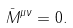Convert formula to latex. <formula><loc_0><loc_0><loc_500><loc_500>\bar { M } ^ { \mu \nu } = 0 .</formula> 